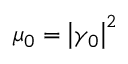<formula> <loc_0><loc_0><loc_500><loc_500>\mu _ { 0 } = \left | \gamma _ { 0 } \right | ^ { 2 }</formula> 